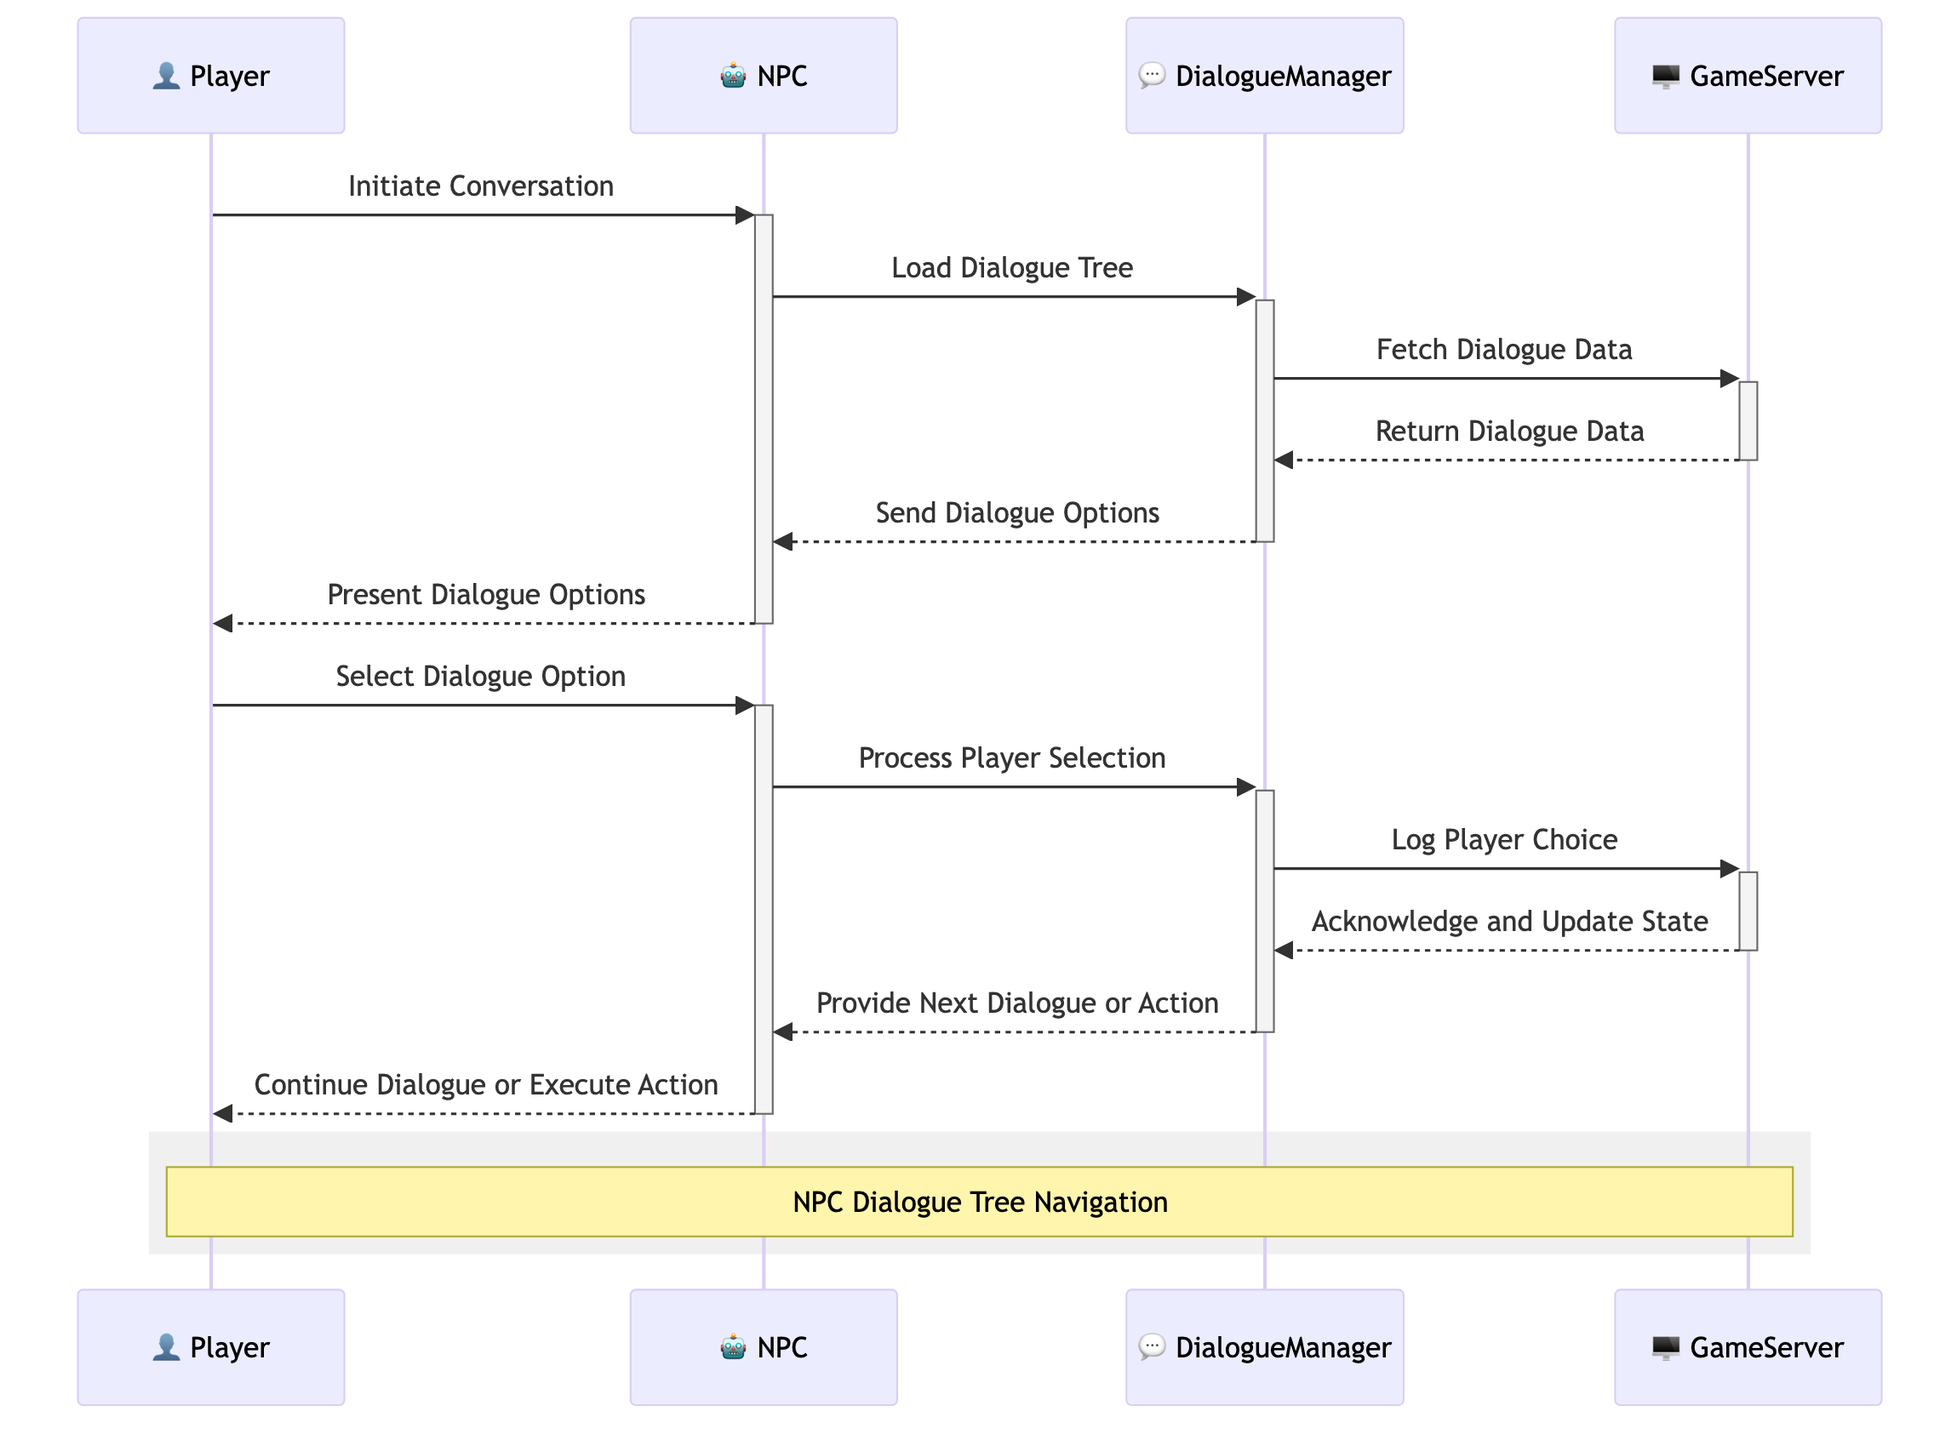What is the first message in the diagram? The first message in the diagram is "Initiate Conversation" which is shown as the Player communicating with the NPC.
Answer: Initiate Conversation How many actors are involved in the dialogue sequence? There are four actors involved in the dialogue sequence: Player, NPC, DialogueManager, and GameServer.
Answer: Four Which actor receives the "Return Dialogue Data"? The "Return Dialogue Data" message is received by the DialogueManager from the GameServer.
Answer: DialogueManager What action does the NPC take after presenting dialogue options? After presenting dialogue options, the NPC processes the player's selection.
Answer: Process Player Selection How many messages are sent from the DialogueManager to the GameServer? There are two messages sent from the DialogueManager to the GameServer: "Fetch Dialogue Data" and "Log Player Choice."
Answer: Two What does the NPC do after processing the player selection? After processing the player selection, the NPC continues the dialogue or executes an action.
Answer: Continue Dialogue or Execute Action Which message signifies the player's engagement with the NPC? The player engages with the NPC through the message "Select Dialogue Option."
Answer: Select Dialogue Option What type of message is sent from the GameServer to the DialogueManager after logging the player choice? The message sent from GameServer to DialogueManager after logging the player choice is "Acknowledge and Update State."
Answer: Acknowledge and Update State 